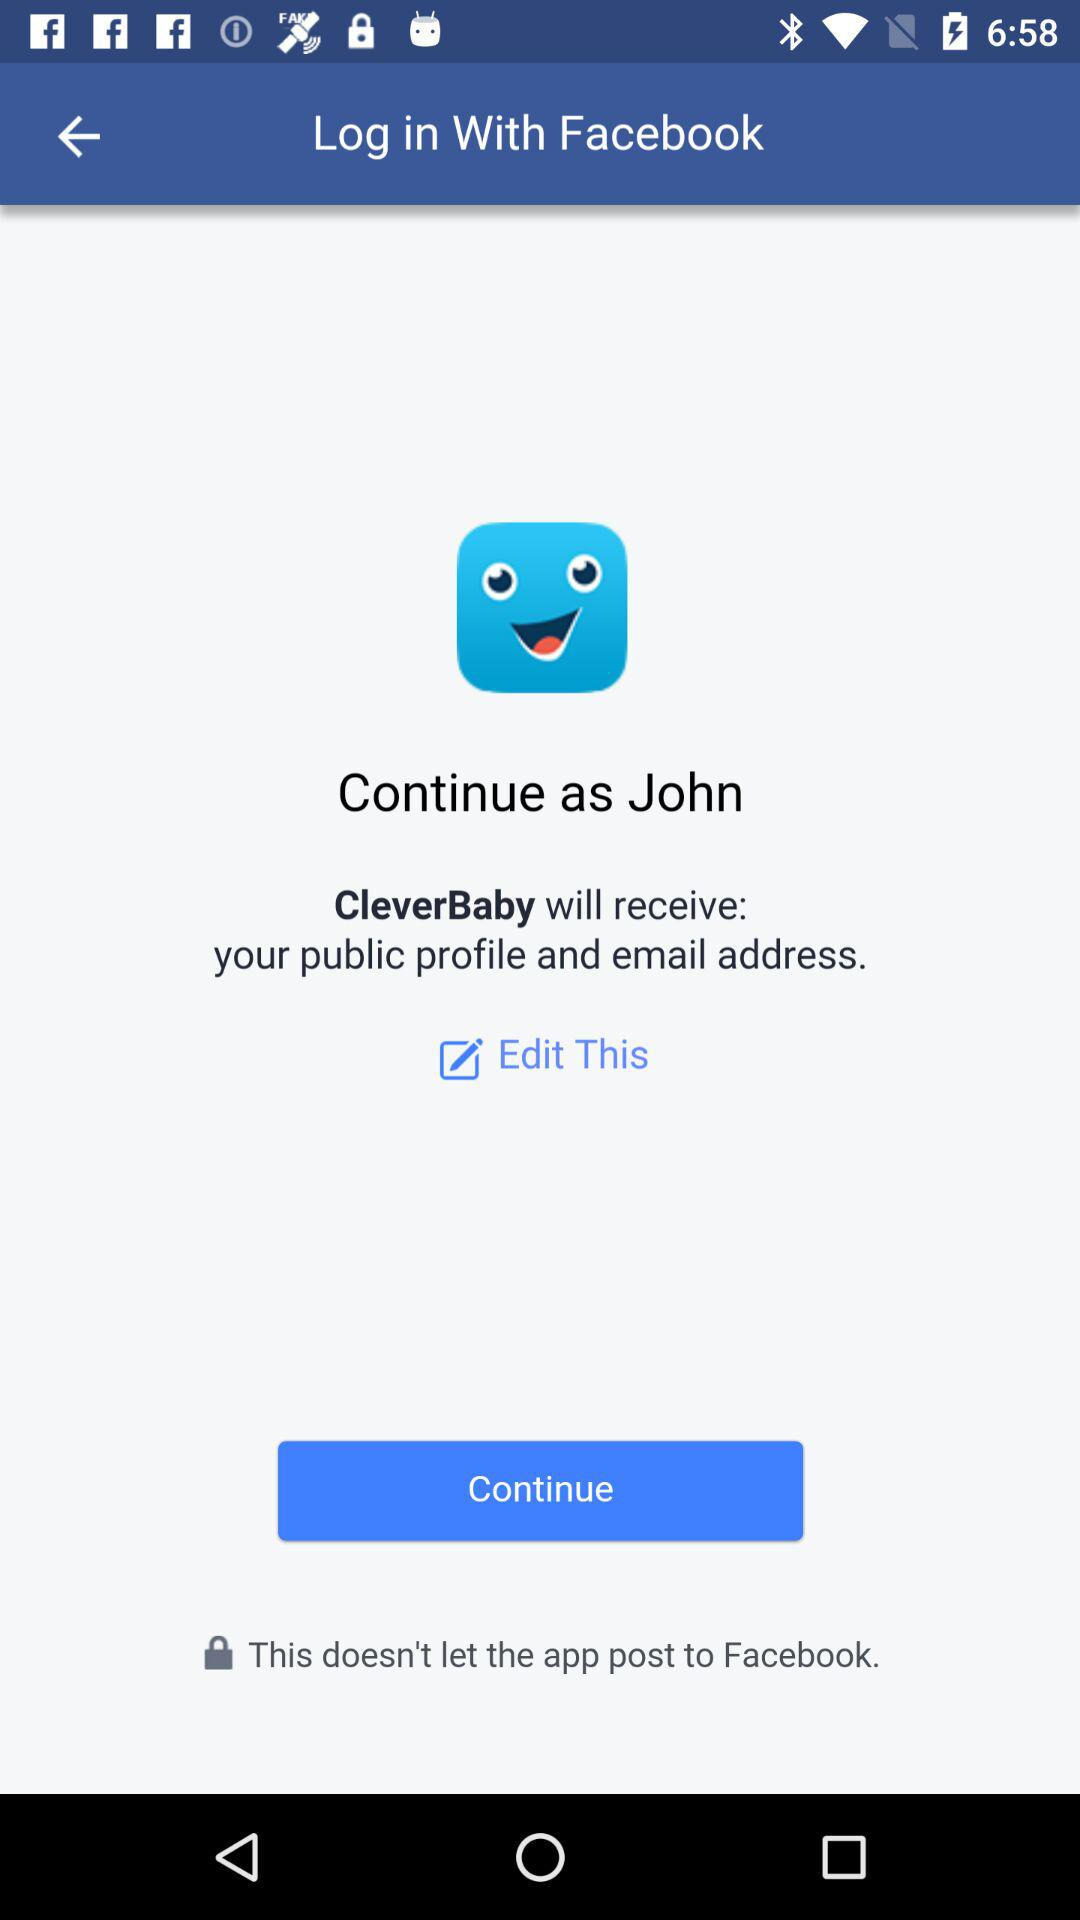What is the user's last name?
When the provided information is insufficient, respond with <no answer>. <no answer> 